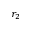Convert formula to latex. <formula><loc_0><loc_0><loc_500><loc_500>r _ { 2 }</formula> 